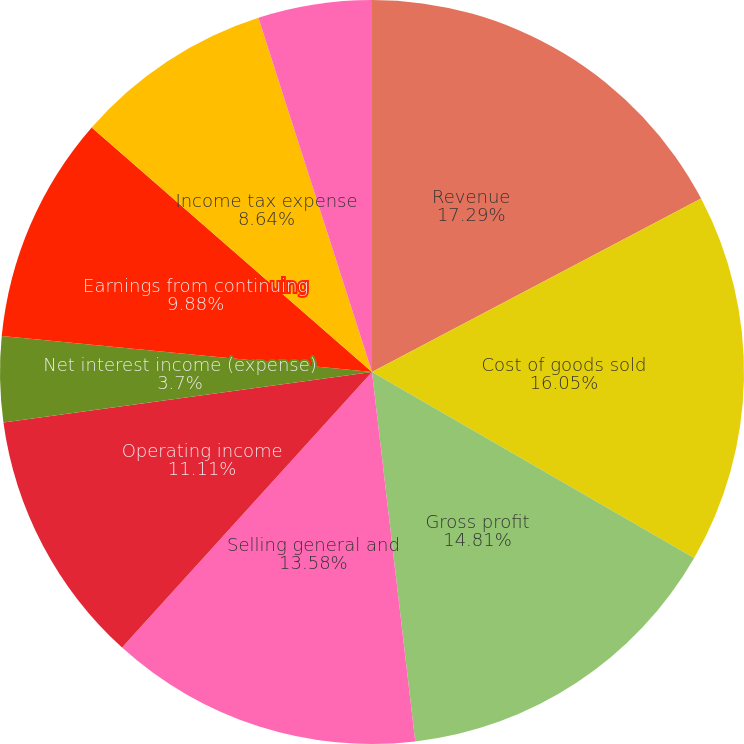Convert chart. <chart><loc_0><loc_0><loc_500><loc_500><pie_chart><fcel>Revenue<fcel>Cost of goods sold<fcel>Gross profit<fcel>Selling general and<fcel>Operating income<fcel>Net interest income (expense)<fcel>Earnings from continuing<fcel>Income tax expense<fcel>Net earnings<nl><fcel>17.28%<fcel>16.05%<fcel>14.81%<fcel>13.58%<fcel>11.11%<fcel>3.7%<fcel>9.88%<fcel>8.64%<fcel>4.94%<nl></chart> 